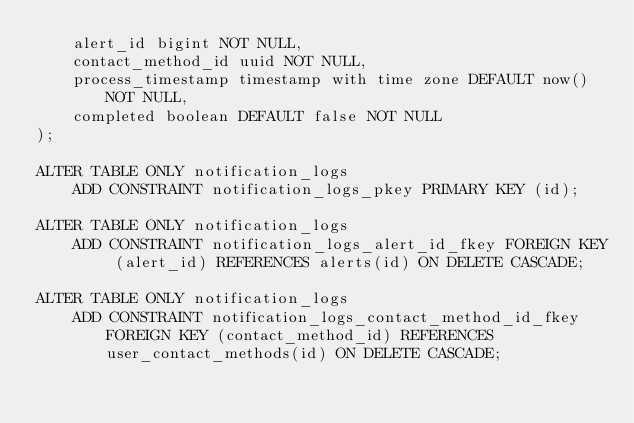<code> <loc_0><loc_0><loc_500><loc_500><_SQL_>    alert_id bigint NOT NULL,
    contact_method_id uuid NOT NULL,
    process_timestamp timestamp with time zone DEFAULT now() NOT NULL,
    completed boolean DEFAULT false NOT NULL
);

ALTER TABLE ONLY notification_logs
    ADD CONSTRAINT notification_logs_pkey PRIMARY KEY (id);

ALTER TABLE ONLY notification_logs
    ADD CONSTRAINT notification_logs_alert_id_fkey FOREIGN KEY (alert_id) REFERENCES alerts(id) ON DELETE CASCADE;

ALTER TABLE ONLY notification_logs
    ADD CONSTRAINT notification_logs_contact_method_id_fkey FOREIGN KEY (contact_method_id) REFERENCES user_contact_methods(id) ON DELETE CASCADE;

</code> 